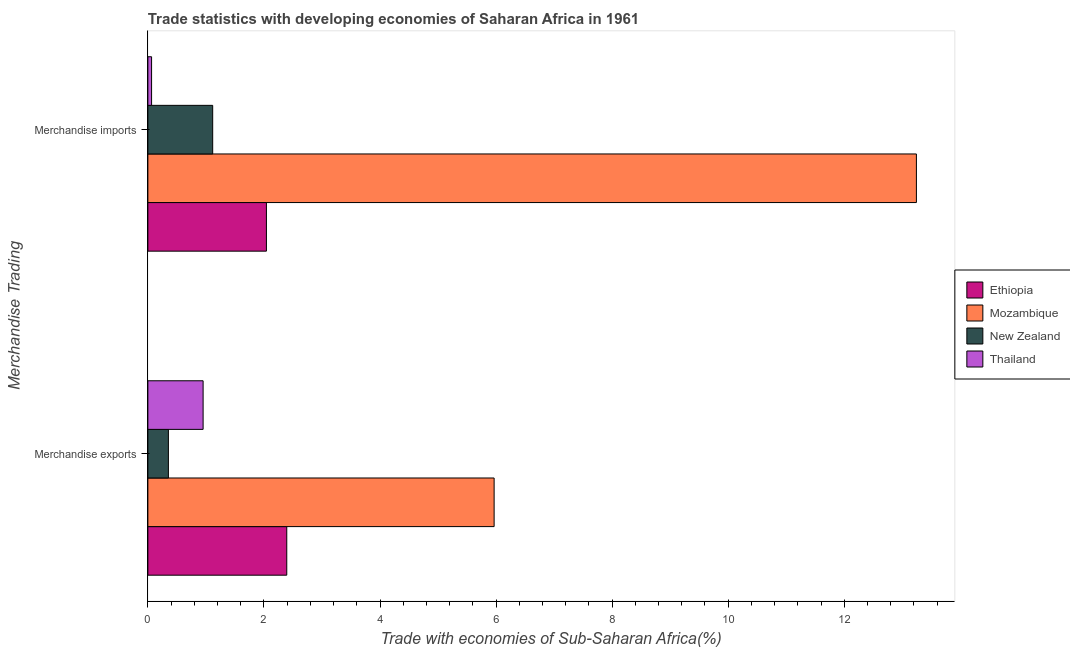How many different coloured bars are there?
Ensure brevity in your answer.  4. How many groups of bars are there?
Offer a terse response. 2. Are the number of bars per tick equal to the number of legend labels?
Your response must be concise. Yes. What is the label of the 1st group of bars from the top?
Keep it short and to the point. Merchandise imports. What is the merchandise exports in Thailand?
Your response must be concise. 0.95. Across all countries, what is the maximum merchandise imports?
Keep it short and to the point. 13.24. Across all countries, what is the minimum merchandise imports?
Provide a succinct answer. 0.06. In which country was the merchandise exports maximum?
Offer a very short reply. Mozambique. In which country was the merchandise exports minimum?
Provide a succinct answer. New Zealand. What is the total merchandise exports in the graph?
Your response must be concise. 9.67. What is the difference between the merchandise exports in New Zealand and that in Ethiopia?
Provide a succinct answer. -2.04. What is the difference between the merchandise exports in Mozambique and the merchandise imports in Thailand?
Give a very brief answer. 5.9. What is the average merchandise imports per country?
Provide a short and direct response. 4.12. What is the difference between the merchandise exports and merchandise imports in Ethiopia?
Your answer should be very brief. 0.35. What is the ratio of the merchandise imports in Thailand to that in New Zealand?
Your response must be concise. 0.06. In how many countries, is the merchandise exports greater than the average merchandise exports taken over all countries?
Your response must be concise. 1. What does the 4th bar from the top in Merchandise exports represents?
Keep it short and to the point. Ethiopia. What does the 3rd bar from the bottom in Merchandise exports represents?
Provide a short and direct response. New Zealand. How many bars are there?
Ensure brevity in your answer.  8. Are all the bars in the graph horizontal?
Your response must be concise. Yes. Are the values on the major ticks of X-axis written in scientific E-notation?
Your response must be concise. No. How many legend labels are there?
Make the answer very short. 4. How are the legend labels stacked?
Make the answer very short. Vertical. What is the title of the graph?
Give a very brief answer. Trade statistics with developing economies of Saharan Africa in 1961. What is the label or title of the X-axis?
Give a very brief answer. Trade with economies of Sub-Saharan Africa(%). What is the label or title of the Y-axis?
Keep it short and to the point. Merchandise Trading. What is the Trade with economies of Sub-Saharan Africa(%) in Ethiopia in Merchandise exports?
Provide a short and direct response. 2.39. What is the Trade with economies of Sub-Saharan Africa(%) in Mozambique in Merchandise exports?
Your answer should be very brief. 5.97. What is the Trade with economies of Sub-Saharan Africa(%) in New Zealand in Merchandise exports?
Your answer should be very brief. 0.35. What is the Trade with economies of Sub-Saharan Africa(%) in Thailand in Merchandise exports?
Your answer should be compact. 0.95. What is the Trade with economies of Sub-Saharan Africa(%) in Ethiopia in Merchandise imports?
Your answer should be compact. 2.04. What is the Trade with economies of Sub-Saharan Africa(%) in Mozambique in Merchandise imports?
Give a very brief answer. 13.24. What is the Trade with economies of Sub-Saharan Africa(%) of New Zealand in Merchandise imports?
Provide a short and direct response. 1.12. What is the Trade with economies of Sub-Saharan Africa(%) of Thailand in Merchandise imports?
Offer a terse response. 0.06. Across all Merchandise Trading, what is the maximum Trade with economies of Sub-Saharan Africa(%) in Ethiopia?
Offer a very short reply. 2.39. Across all Merchandise Trading, what is the maximum Trade with economies of Sub-Saharan Africa(%) of Mozambique?
Make the answer very short. 13.24. Across all Merchandise Trading, what is the maximum Trade with economies of Sub-Saharan Africa(%) of New Zealand?
Offer a very short reply. 1.12. Across all Merchandise Trading, what is the maximum Trade with economies of Sub-Saharan Africa(%) of Thailand?
Your response must be concise. 0.95. Across all Merchandise Trading, what is the minimum Trade with economies of Sub-Saharan Africa(%) in Ethiopia?
Your response must be concise. 2.04. Across all Merchandise Trading, what is the minimum Trade with economies of Sub-Saharan Africa(%) in Mozambique?
Ensure brevity in your answer.  5.97. Across all Merchandise Trading, what is the minimum Trade with economies of Sub-Saharan Africa(%) in New Zealand?
Offer a terse response. 0.35. Across all Merchandise Trading, what is the minimum Trade with economies of Sub-Saharan Africa(%) in Thailand?
Ensure brevity in your answer.  0.06. What is the total Trade with economies of Sub-Saharan Africa(%) in Ethiopia in the graph?
Offer a terse response. 4.44. What is the total Trade with economies of Sub-Saharan Africa(%) of Mozambique in the graph?
Your response must be concise. 19.21. What is the total Trade with economies of Sub-Saharan Africa(%) of New Zealand in the graph?
Make the answer very short. 1.47. What is the total Trade with economies of Sub-Saharan Africa(%) in Thailand in the graph?
Provide a succinct answer. 1.02. What is the difference between the Trade with economies of Sub-Saharan Africa(%) of Ethiopia in Merchandise exports and that in Merchandise imports?
Offer a very short reply. 0.35. What is the difference between the Trade with economies of Sub-Saharan Africa(%) of Mozambique in Merchandise exports and that in Merchandise imports?
Offer a very short reply. -7.28. What is the difference between the Trade with economies of Sub-Saharan Africa(%) in New Zealand in Merchandise exports and that in Merchandise imports?
Your answer should be very brief. -0.76. What is the difference between the Trade with economies of Sub-Saharan Africa(%) in Thailand in Merchandise exports and that in Merchandise imports?
Provide a short and direct response. 0.89. What is the difference between the Trade with economies of Sub-Saharan Africa(%) of Ethiopia in Merchandise exports and the Trade with economies of Sub-Saharan Africa(%) of Mozambique in Merchandise imports?
Your answer should be compact. -10.85. What is the difference between the Trade with economies of Sub-Saharan Africa(%) of Ethiopia in Merchandise exports and the Trade with economies of Sub-Saharan Africa(%) of New Zealand in Merchandise imports?
Offer a terse response. 1.28. What is the difference between the Trade with economies of Sub-Saharan Africa(%) in Ethiopia in Merchandise exports and the Trade with economies of Sub-Saharan Africa(%) in Thailand in Merchandise imports?
Your response must be concise. 2.33. What is the difference between the Trade with economies of Sub-Saharan Africa(%) of Mozambique in Merchandise exports and the Trade with economies of Sub-Saharan Africa(%) of New Zealand in Merchandise imports?
Give a very brief answer. 4.85. What is the difference between the Trade with economies of Sub-Saharan Africa(%) in Mozambique in Merchandise exports and the Trade with economies of Sub-Saharan Africa(%) in Thailand in Merchandise imports?
Make the answer very short. 5.9. What is the difference between the Trade with economies of Sub-Saharan Africa(%) of New Zealand in Merchandise exports and the Trade with economies of Sub-Saharan Africa(%) of Thailand in Merchandise imports?
Offer a very short reply. 0.29. What is the average Trade with economies of Sub-Saharan Africa(%) in Ethiopia per Merchandise Trading?
Your response must be concise. 2.22. What is the average Trade with economies of Sub-Saharan Africa(%) in Mozambique per Merchandise Trading?
Your response must be concise. 9.61. What is the average Trade with economies of Sub-Saharan Africa(%) of New Zealand per Merchandise Trading?
Your answer should be very brief. 0.74. What is the average Trade with economies of Sub-Saharan Africa(%) of Thailand per Merchandise Trading?
Your answer should be very brief. 0.51. What is the difference between the Trade with economies of Sub-Saharan Africa(%) in Ethiopia and Trade with economies of Sub-Saharan Africa(%) in Mozambique in Merchandise exports?
Provide a succinct answer. -3.57. What is the difference between the Trade with economies of Sub-Saharan Africa(%) in Ethiopia and Trade with economies of Sub-Saharan Africa(%) in New Zealand in Merchandise exports?
Offer a terse response. 2.04. What is the difference between the Trade with economies of Sub-Saharan Africa(%) of Ethiopia and Trade with economies of Sub-Saharan Africa(%) of Thailand in Merchandise exports?
Your answer should be compact. 1.44. What is the difference between the Trade with economies of Sub-Saharan Africa(%) in Mozambique and Trade with economies of Sub-Saharan Africa(%) in New Zealand in Merchandise exports?
Offer a terse response. 5.61. What is the difference between the Trade with economies of Sub-Saharan Africa(%) of Mozambique and Trade with economies of Sub-Saharan Africa(%) of Thailand in Merchandise exports?
Keep it short and to the point. 5.01. What is the difference between the Trade with economies of Sub-Saharan Africa(%) in New Zealand and Trade with economies of Sub-Saharan Africa(%) in Thailand in Merchandise exports?
Make the answer very short. -0.6. What is the difference between the Trade with economies of Sub-Saharan Africa(%) in Ethiopia and Trade with economies of Sub-Saharan Africa(%) in Mozambique in Merchandise imports?
Offer a terse response. -11.2. What is the difference between the Trade with economies of Sub-Saharan Africa(%) of Ethiopia and Trade with economies of Sub-Saharan Africa(%) of New Zealand in Merchandise imports?
Provide a short and direct response. 0.93. What is the difference between the Trade with economies of Sub-Saharan Africa(%) of Ethiopia and Trade with economies of Sub-Saharan Africa(%) of Thailand in Merchandise imports?
Provide a succinct answer. 1.98. What is the difference between the Trade with economies of Sub-Saharan Africa(%) of Mozambique and Trade with economies of Sub-Saharan Africa(%) of New Zealand in Merchandise imports?
Your answer should be compact. 12.13. What is the difference between the Trade with economies of Sub-Saharan Africa(%) in Mozambique and Trade with economies of Sub-Saharan Africa(%) in Thailand in Merchandise imports?
Give a very brief answer. 13.18. What is the difference between the Trade with economies of Sub-Saharan Africa(%) in New Zealand and Trade with economies of Sub-Saharan Africa(%) in Thailand in Merchandise imports?
Make the answer very short. 1.05. What is the ratio of the Trade with economies of Sub-Saharan Africa(%) of Ethiopia in Merchandise exports to that in Merchandise imports?
Offer a terse response. 1.17. What is the ratio of the Trade with economies of Sub-Saharan Africa(%) of Mozambique in Merchandise exports to that in Merchandise imports?
Offer a very short reply. 0.45. What is the ratio of the Trade with economies of Sub-Saharan Africa(%) of New Zealand in Merchandise exports to that in Merchandise imports?
Offer a terse response. 0.32. What is the ratio of the Trade with economies of Sub-Saharan Africa(%) in Thailand in Merchandise exports to that in Merchandise imports?
Your answer should be very brief. 14.86. What is the difference between the highest and the second highest Trade with economies of Sub-Saharan Africa(%) in Ethiopia?
Make the answer very short. 0.35. What is the difference between the highest and the second highest Trade with economies of Sub-Saharan Africa(%) of Mozambique?
Provide a short and direct response. 7.28. What is the difference between the highest and the second highest Trade with economies of Sub-Saharan Africa(%) in New Zealand?
Keep it short and to the point. 0.76. What is the difference between the highest and the second highest Trade with economies of Sub-Saharan Africa(%) of Thailand?
Keep it short and to the point. 0.89. What is the difference between the highest and the lowest Trade with economies of Sub-Saharan Africa(%) in Ethiopia?
Your response must be concise. 0.35. What is the difference between the highest and the lowest Trade with economies of Sub-Saharan Africa(%) of Mozambique?
Make the answer very short. 7.28. What is the difference between the highest and the lowest Trade with economies of Sub-Saharan Africa(%) in New Zealand?
Ensure brevity in your answer.  0.76. What is the difference between the highest and the lowest Trade with economies of Sub-Saharan Africa(%) in Thailand?
Make the answer very short. 0.89. 